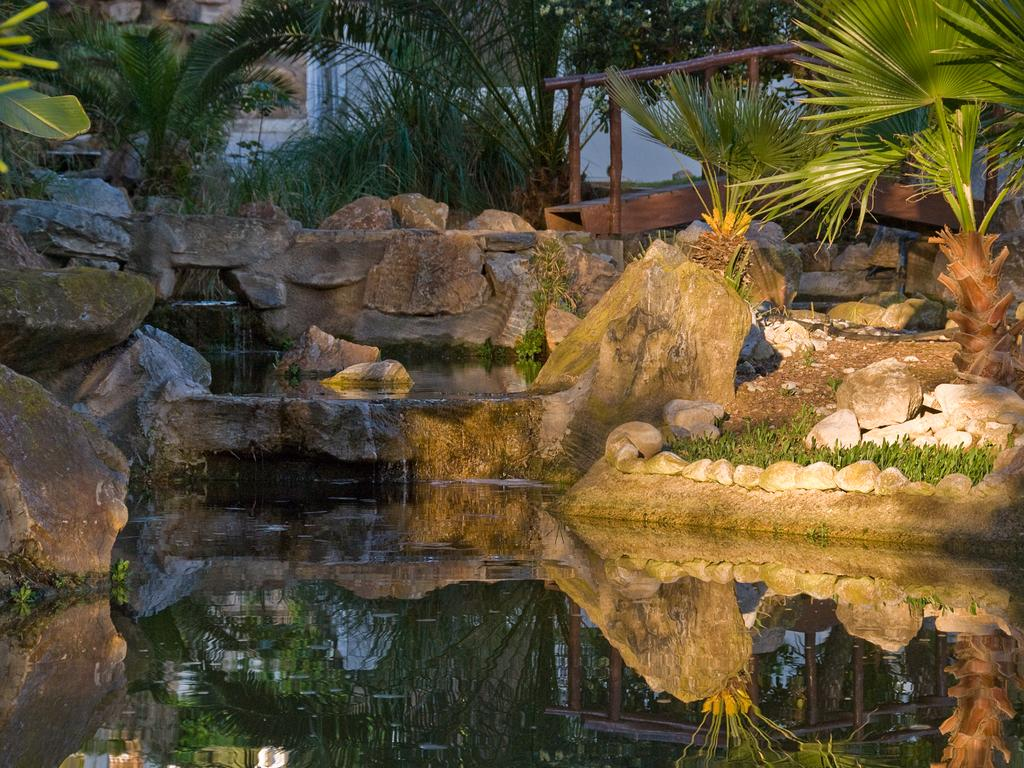What is the primary element visible in the picture? There is water in the picture. What other natural elements can be seen in the picture? There are rocks, trees, and plants in the picture. Are there any man-made objects visible in the picture? Yes, there are wooden objects and other objects on the ground in the picture. What type of toothbrush can be seen in the picture? There is no toothbrush present in the picture. How deep is the hole in the picture? There is no hole visible in the picture. 